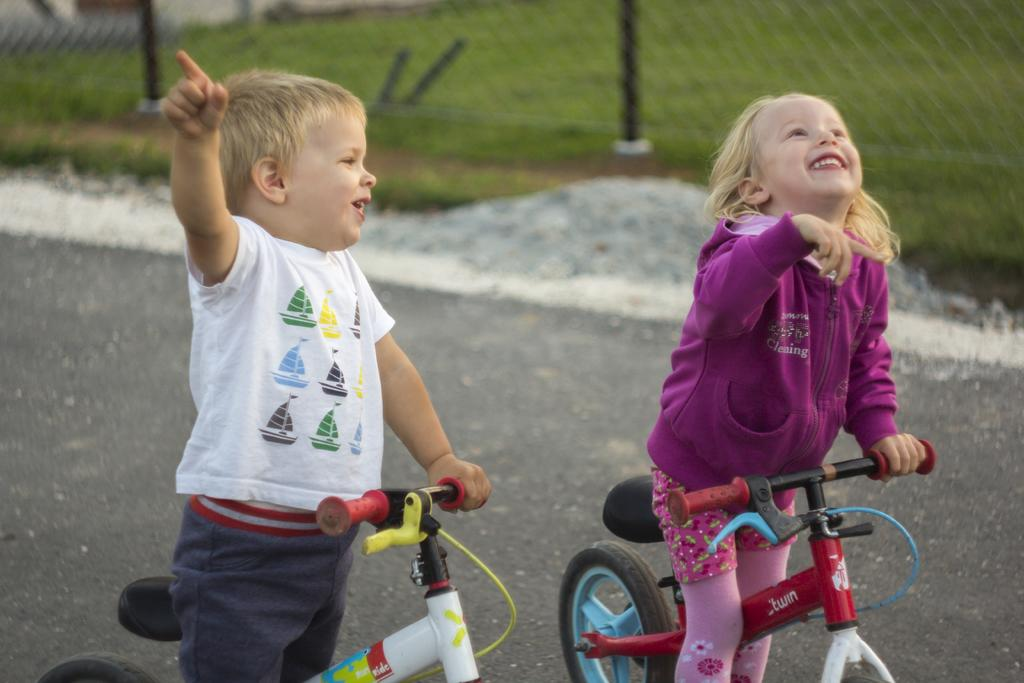Who is present in the image? There is a small boy and a small girl in the image. What are the boy and girl doing in the image? The boy and girl are riding a bicycle together. What can be seen in the background of the image? There is a garden fence in the image. What type of waves can be seen in the image? There are no waves present in the image; it features a small boy and girl riding a bicycle with a garden fence in the background. 